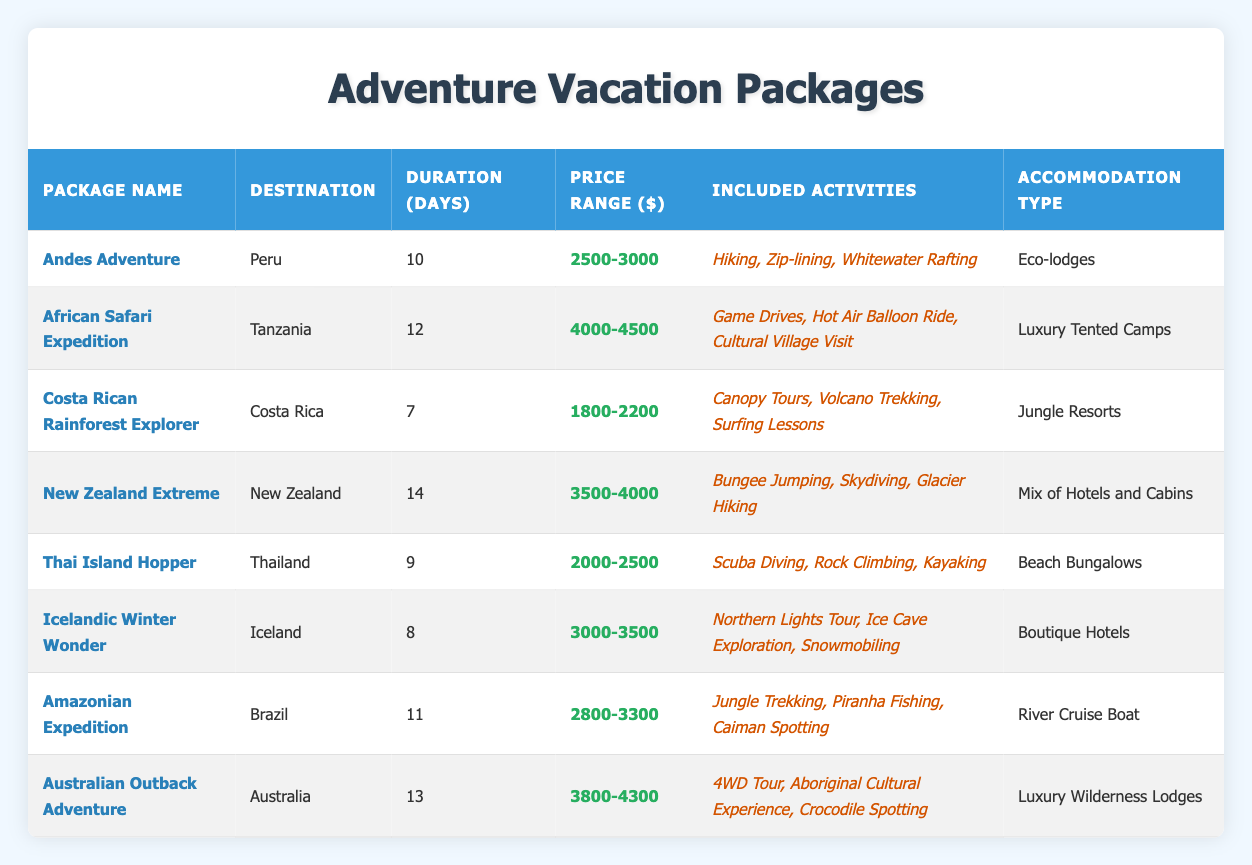What is the price range for the "Thai Island Hopper" package? The price range for the "Thai Island Hopper" package can be directly found by looking at the corresponding row in the table, which lists "2000-2500" as the price range.
Answer: 2000-2500 How many days does the "African Safari Expedition" last? To answer this, I can check the "Duration (Days)" column for the "African Safari Expedition" package in the table. It shows that the duration is 12 days.
Answer: 12 What is the total duration of all the vacation packages combined? To calculate the total duration, I add up the durations from each package: 10 + 12 + 7 + 14 + 9 + 8 + 11 + 13 = 84 days.
Answer: 84 Is "Glacier Hiking" included in the "New Zealand Extreme" package? Looking under the "Included Activities" for the "New Zealand Extreme" row, I see "Bungee Jumping, Skydiving, Glacier Hiking". Since "Glacier Hiking" is mentioned, the answer is yes.
Answer: Yes Which package offers the "Caiman Spotting" activity? By scanning the included activities in each row, I find that "Caiman Spotting" is listed under the "Amazonian Expedition" package.
Answer: Amazonian Expedition What is the average price range of all packages? First, I find the midpoints of the price ranges for each package: (2750 + 4250 + 2000 + 3750 + 2250 + 3250 + 3050 + 4050) = 22600. Since there are 8 packages, the average price range is 22600 / 8 = 2825.
Answer: 2825 Are all packages 10 days or longer? Evaluating the "Duration (Days)" for each package reveals that "Costa Rican Rainforest Explorer" has only 7 days, making this statement false.
Answer: No Which destination has the highest price range? To find the highest price range, I compare the price ranges for each package. "African Safari Expedition" has the highest range of 4000-4500.
Answer: Tanzania 